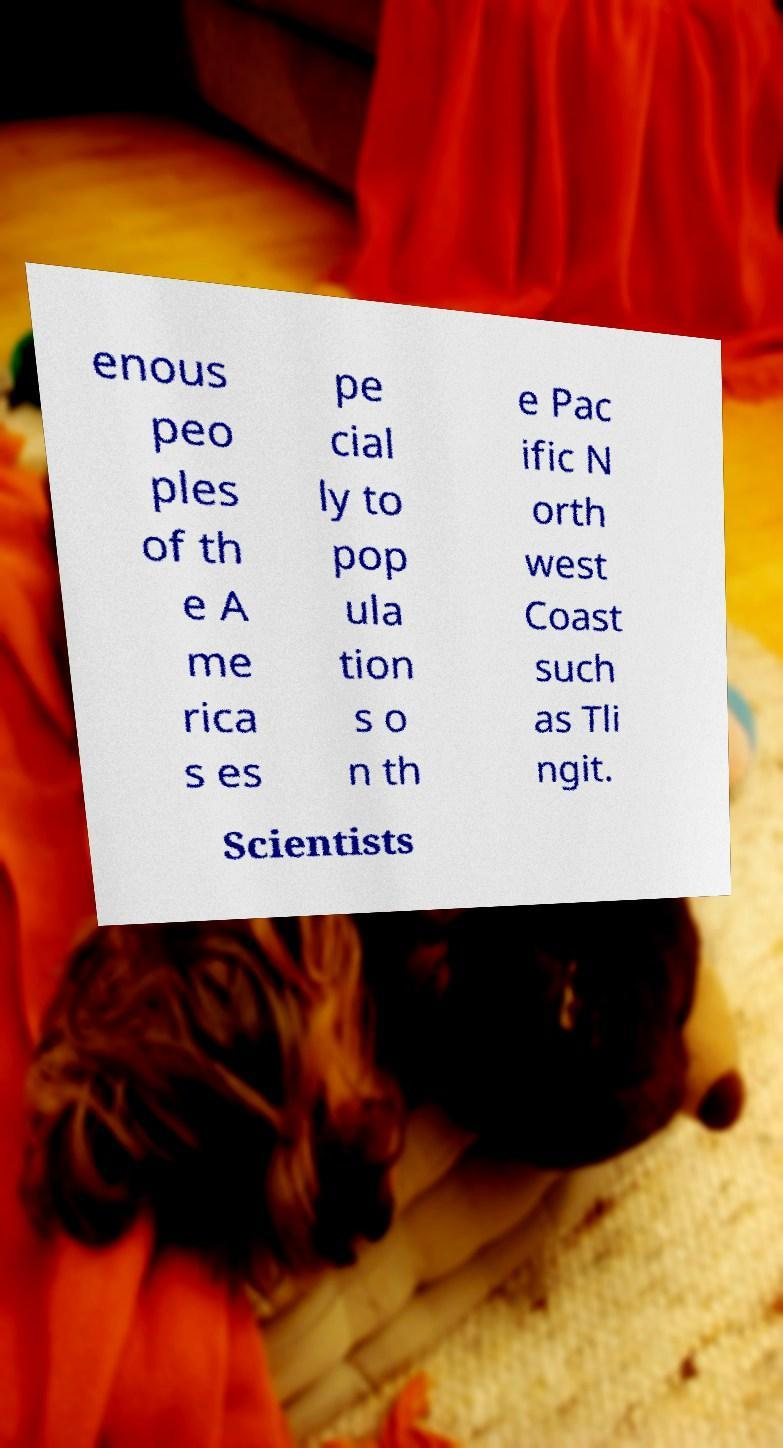Please read and relay the text visible in this image. What does it say? enous peo ples of th e A me rica s es pe cial ly to pop ula tion s o n th e Pac ific N orth west Coast such as Tli ngit. Scientists 